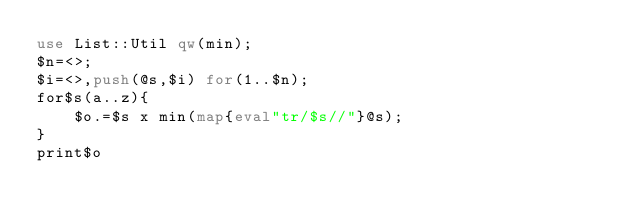Convert code to text. <code><loc_0><loc_0><loc_500><loc_500><_Perl_>use List::Util qw(min);
$n=<>;
$i=<>,push(@s,$i) for(1..$n);
for$s(a..z){
    $o.=$s x min(map{eval"tr/$s//"}@s);
}
print$o</code> 